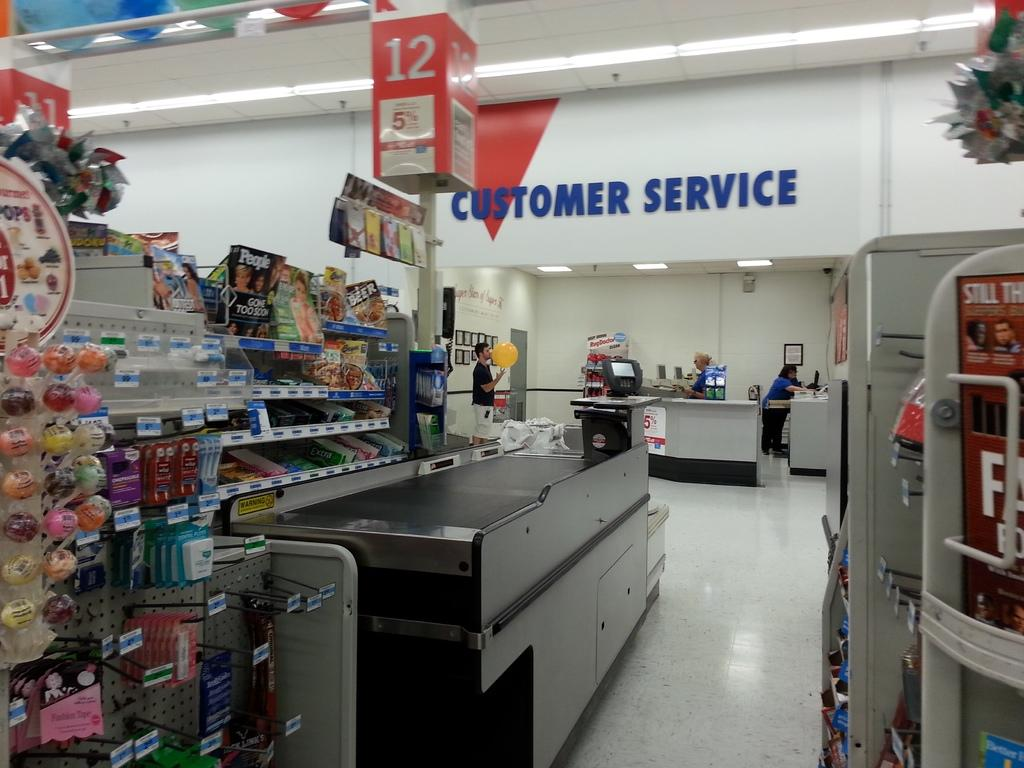<image>
Share a concise interpretation of the image provided. Customer service waits empty for customers to come need help 